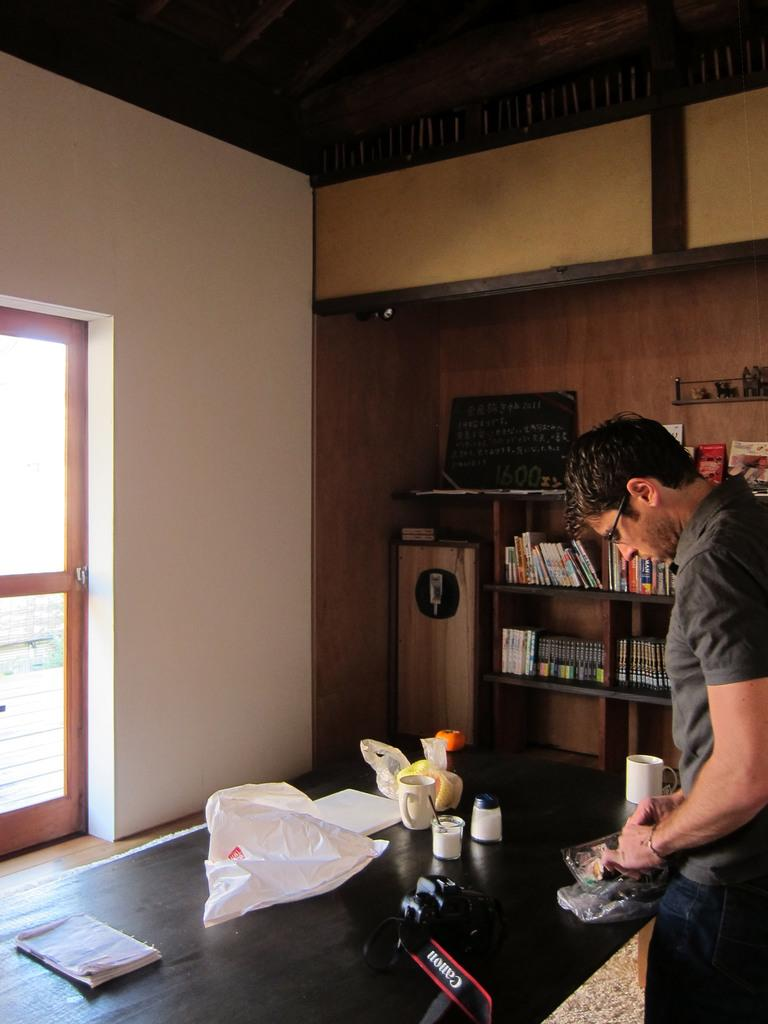<image>
Render a clear and concise summary of the photo. A man stands next to a cafe table with a Canon camera on it. 